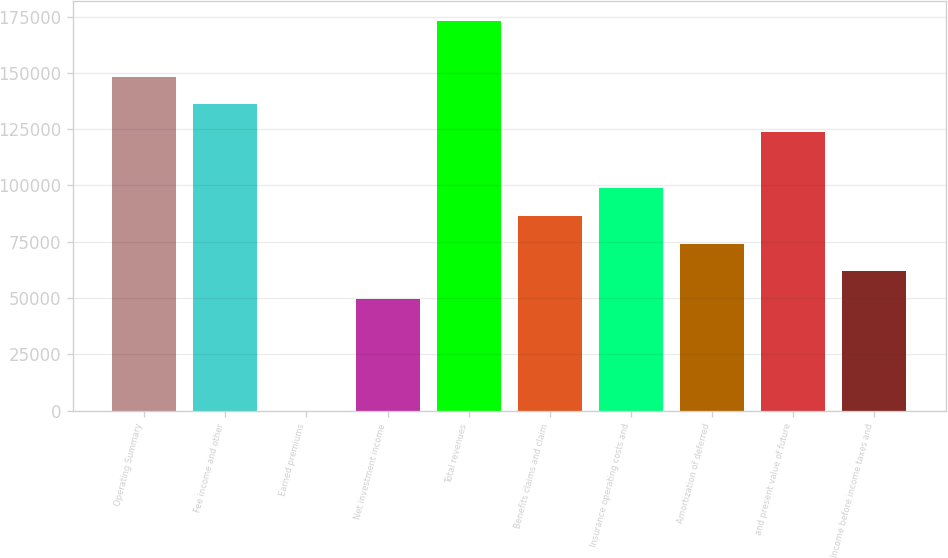<chart> <loc_0><loc_0><loc_500><loc_500><bar_chart><fcel>Operating Summary<fcel>Fee income and other<fcel>Earned premiums<fcel>Net investment income<fcel>Total revenues<fcel>Benefits claims and claim<fcel>Insurance operating costs and<fcel>Amortization of deferred<fcel>and present value of future<fcel>Income before income taxes and<nl><fcel>148343<fcel>135983<fcel>31<fcel>49468.2<fcel>173061<fcel>86546.1<fcel>98905.4<fcel>74186.8<fcel>123624<fcel>61827.5<nl></chart> 